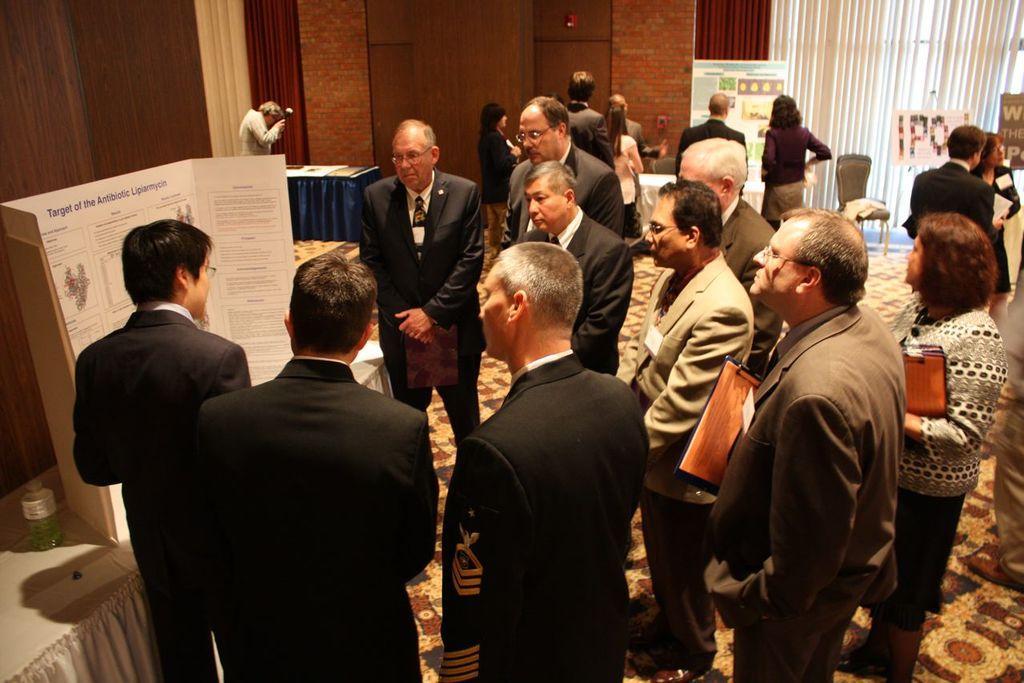Could you give a brief overview of what you see in this image? In this image I can see number of persons wearing blazers are standing on the ground. I can see a white colored table and on it I can see a water bottle and a board. In the background I can see few persons standing, few boards, the brown colored wall, few brown colored curtains and the window blind. 